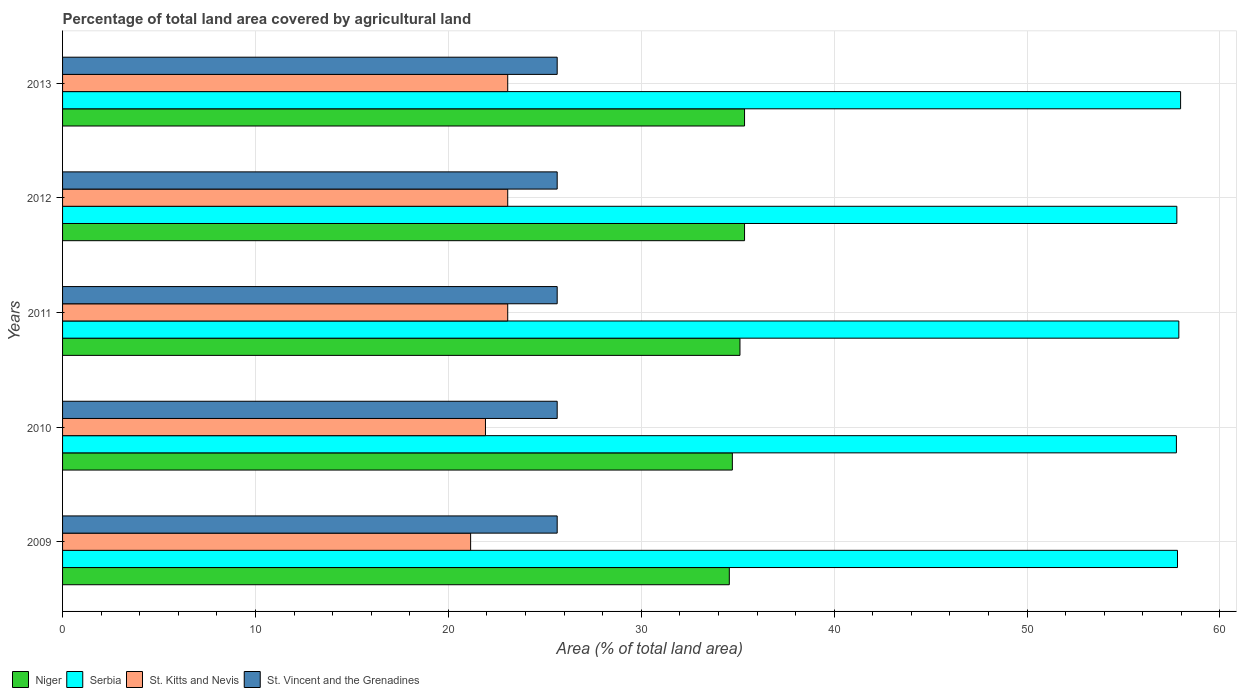How many different coloured bars are there?
Ensure brevity in your answer.  4. Are the number of bars per tick equal to the number of legend labels?
Offer a terse response. Yes. What is the percentage of agricultural land in St. Kitts and Nevis in 2013?
Provide a short and direct response. 23.08. Across all years, what is the maximum percentage of agricultural land in St. Vincent and the Grenadines?
Offer a very short reply. 25.64. Across all years, what is the minimum percentage of agricultural land in Serbia?
Give a very brief answer. 57.74. In which year was the percentage of agricultural land in Niger maximum?
Make the answer very short. 2012. In which year was the percentage of agricultural land in St. Kitts and Nevis minimum?
Offer a very short reply. 2009. What is the total percentage of agricultural land in Niger in the graph?
Make the answer very short. 175.11. What is the difference between the percentage of agricultural land in St. Kitts and Nevis in 2009 and that in 2010?
Make the answer very short. -0.77. What is the difference between the percentage of agricultural land in St. Vincent and the Grenadines in 2011 and the percentage of agricultural land in Serbia in 2013?
Your answer should be compact. -32.32. What is the average percentage of agricultural land in Serbia per year?
Your answer should be compact. 57.83. In the year 2013, what is the difference between the percentage of agricultural land in St. Kitts and Nevis and percentage of agricultural land in Niger?
Provide a short and direct response. -12.28. In how many years, is the percentage of agricultural land in St. Vincent and the Grenadines greater than 18 %?
Provide a succinct answer. 5. What is the ratio of the percentage of agricultural land in Niger in 2010 to that in 2012?
Offer a terse response. 0.98. What is the difference between the highest and the lowest percentage of agricultural land in Serbia?
Offer a very short reply. 0.22. In how many years, is the percentage of agricultural land in St. Vincent and the Grenadines greater than the average percentage of agricultural land in St. Vincent and the Grenadines taken over all years?
Ensure brevity in your answer.  0. Is it the case that in every year, the sum of the percentage of agricultural land in St. Kitts and Nevis and percentage of agricultural land in Serbia is greater than the sum of percentage of agricultural land in Niger and percentage of agricultural land in St. Vincent and the Grenadines?
Provide a succinct answer. Yes. What does the 2nd bar from the top in 2013 represents?
Make the answer very short. St. Kitts and Nevis. What does the 4th bar from the bottom in 2012 represents?
Offer a very short reply. St. Vincent and the Grenadines. Is it the case that in every year, the sum of the percentage of agricultural land in Niger and percentage of agricultural land in St. Kitts and Nevis is greater than the percentage of agricultural land in St. Vincent and the Grenadines?
Provide a short and direct response. Yes. How many bars are there?
Your answer should be compact. 20. Are all the bars in the graph horizontal?
Keep it short and to the point. Yes. How many years are there in the graph?
Keep it short and to the point. 5. Does the graph contain grids?
Offer a terse response. Yes. Where does the legend appear in the graph?
Provide a short and direct response. Bottom left. How many legend labels are there?
Offer a very short reply. 4. How are the legend labels stacked?
Your response must be concise. Horizontal. What is the title of the graph?
Make the answer very short. Percentage of total land area covered by agricultural land. What is the label or title of the X-axis?
Ensure brevity in your answer.  Area (% of total land area). What is the Area (% of total land area) of Niger in 2009?
Keep it short and to the point. 34.56. What is the Area (% of total land area) of Serbia in 2009?
Offer a very short reply. 57.8. What is the Area (% of total land area) in St. Kitts and Nevis in 2009?
Your answer should be compact. 21.15. What is the Area (% of total land area) of St. Vincent and the Grenadines in 2009?
Your response must be concise. 25.64. What is the Area (% of total land area) in Niger in 2010?
Make the answer very short. 34.72. What is the Area (% of total land area) of Serbia in 2010?
Make the answer very short. 57.74. What is the Area (% of total land area) in St. Kitts and Nevis in 2010?
Make the answer very short. 21.92. What is the Area (% of total land area) of St. Vincent and the Grenadines in 2010?
Offer a terse response. 25.64. What is the Area (% of total land area) in Niger in 2011?
Your answer should be very brief. 35.12. What is the Area (% of total land area) in Serbia in 2011?
Offer a very short reply. 57.87. What is the Area (% of total land area) in St. Kitts and Nevis in 2011?
Provide a short and direct response. 23.08. What is the Area (% of total land area) in St. Vincent and the Grenadines in 2011?
Provide a succinct answer. 25.64. What is the Area (% of total land area) of Niger in 2012?
Make the answer very short. 35.35. What is the Area (% of total land area) of Serbia in 2012?
Your answer should be compact. 57.76. What is the Area (% of total land area) in St. Kitts and Nevis in 2012?
Ensure brevity in your answer.  23.08. What is the Area (% of total land area) of St. Vincent and the Grenadines in 2012?
Offer a terse response. 25.64. What is the Area (% of total land area) of Niger in 2013?
Your response must be concise. 35.35. What is the Area (% of total land area) of Serbia in 2013?
Give a very brief answer. 57.96. What is the Area (% of total land area) of St. Kitts and Nevis in 2013?
Ensure brevity in your answer.  23.08. What is the Area (% of total land area) in St. Vincent and the Grenadines in 2013?
Give a very brief answer. 25.64. Across all years, what is the maximum Area (% of total land area) of Niger?
Offer a very short reply. 35.35. Across all years, what is the maximum Area (% of total land area) of Serbia?
Make the answer very short. 57.96. Across all years, what is the maximum Area (% of total land area) of St. Kitts and Nevis?
Keep it short and to the point. 23.08. Across all years, what is the maximum Area (% of total land area) of St. Vincent and the Grenadines?
Your answer should be very brief. 25.64. Across all years, what is the minimum Area (% of total land area) in Niger?
Make the answer very short. 34.56. Across all years, what is the minimum Area (% of total land area) of Serbia?
Give a very brief answer. 57.74. Across all years, what is the minimum Area (% of total land area) in St. Kitts and Nevis?
Ensure brevity in your answer.  21.15. Across all years, what is the minimum Area (% of total land area) in St. Vincent and the Grenadines?
Provide a succinct answer. 25.64. What is the total Area (% of total land area) in Niger in the graph?
Ensure brevity in your answer.  175.11. What is the total Area (% of total land area) in Serbia in the graph?
Provide a succinct answer. 289.13. What is the total Area (% of total land area) in St. Kitts and Nevis in the graph?
Make the answer very short. 112.31. What is the total Area (% of total land area) in St. Vincent and the Grenadines in the graph?
Provide a short and direct response. 128.21. What is the difference between the Area (% of total land area) of Niger in 2009 and that in 2010?
Offer a very short reply. -0.16. What is the difference between the Area (% of total land area) in Serbia in 2009 and that in 2010?
Offer a terse response. 0.06. What is the difference between the Area (% of total land area) in St. Kitts and Nevis in 2009 and that in 2010?
Your answer should be compact. -0.77. What is the difference between the Area (% of total land area) in St. Vincent and the Grenadines in 2009 and that in 2010?
Give a very brief answer. 0. What is the difference between the Area (% of total land area) of Niger in 2009 and that in 2011?
Your answer should be compact. -0.55. What is the difference between the Area (% of total land area) in Serbia in 2009 and that in 2011?
Your answer should be very brief. -0.07. What is the difference between the Area (% of total land area) in St. Kitts and Nevis in 2009 and that in 2011?
Your answer should be very brief. -1.92. What is the difference between the Area (% of total land area) in Niger in 2009 and that in 2012?
Provide a succinct answer. -0.79. What is the difference between the Area (% of total land area) of Serbia in 2009 and that in 2012?
Make the answer very short. 0.03. What is the difference between the Area (% of total land area) in St. Kitts and Nevis in 2009 and that in 2012?
Give a very brief answer. -1.92. What is the difference between the Area (% of total land area) in St. Vincent and the Grenadines in 2009 and that in 2012?
Provide a short and direct response. 0. What is the difference between the Area (% of total land area) in Niger in 2009 and that in 2013?
Your answer should be very brief. -0.79. What is the difference between the Area (% of total land area) in Serbia in 2009 and that in 2013?
Your answer should be compact. -0.16. What is the difference between the Area (% of total land area) in St. Kitts and Nevis in 2009 and that in 2013?
Provide a succinct answer. -1.92. What is the difference between the Area (% of total land area) of St. Vincent and the Grenadines in 2009 and that in 2013?
Keep it short and to the point. 0. What is the difference between the Area (% of total land area) in Niger in 2010 and that in 2011?
Your answer should be very brief. -0.39. What is the difference between the Area (% of total land area) in Serbia in 2010 and that in 2011?
Make the answer very short. -0.13. What is the difference between the Area (% of total land area) of St. Kitts and Nevis in 2010 and that in 2011?
Make the answer very short. -1.15. What is the difference between the Area (% of total land area) of Niger in 2010 and that in 2012?
Keep it short and to the point. -0.63. What is the difference between the Area (% of total land area) of Serbia in 2010 and that in 2012?
Ensure brevity in your answer.  -0.02. What is the difference between the Area (% of total land area) of St. Kitts and Nevis in 2010 and that in 2012?
Make the answer very short. -1.15. What is the difference between the Area (% of total land area) in St. Vincent and the Grenadines in 2010 and that in 2012?
Provide a succinct answer. 0. What is the difference between the Area (% of total land area) of Niger in 2010 and that in 2013?
Ensure brevity in your answer.  -0.63. What is the difference between the Area (% of total land area) in Serbia in 2010 and that in 2013?
Provide a short and direct response. -0.22. What is the difference between the Area (% of total land area) in St. Kitts and Nevis in 2010 and that in 2013?
Ensure brevity in your answer.  -1.15. What is the difference between the Area (% of total land area) of St. Vincent and the Grenadines in 2010 and that in 2013?
Provide a succinct answer. 0. What is the difference between the Area (% of total land area) of Niger in 2011 and that in 2012?
Your answer should be compact. -0.24. What is the difference between the Area (% of total land area) in Serbia in 2011 and that in 2012?
Provide a succinct answer. 0.1. What is the difference between the Area (% of total land area) in Niger in 2011 and that in 2013?
Your response must be concise. -0.24. What is the difference between the Area (% of total land area) of Serbia in 2011 and that in 2013?
Provide a succinct answer. -0.09. What is the difference between the Area (% of total land area) of St. Kitts and Nevis in 2011 and that in 2013?
Your answer should be very brief. 0. What is the difference between the Area (% of total land area) of St. Vincent and the Grenadines in 2011 and that in 2013?
Provide a short and direct response. 0. What is the difference between the Area (% of total land area) of Niger in 2012 and that in 2013?
Keep it short and to the point. 0. What is the difference between the Area (% of total land area) in Serbia in 2012 and that in 2013?
Provide a short and direct response. -0.19. What is the difference between the Area (% of total land area) of St. Kitts and Nevis in 2012 and that in 2013?
Provide a short and direct response. 0. What is the difference between the Area (% of total land area) of St. Vincent and the Grenadines in 2012 and that in 2013?
Your answer should be compact. 0. What is the difference between the Area (% of total land area) in Niger in 2009 and the Area (% of total land area) in Serbia in 2010?
Offer a very short reply. -23.18. What is the difference between the Area (% of total land area) in Niger in 2009 and the Area (% of total land area) in St. Kitts and Nevis in 2010?
Make the answer very short. 12.64. What is the difference between the Area (% of total land area) in Niger in 2009 and the Area (% of total land area) in St. Vincent and the Grenadines in 2010?
Your response must be concise. 8.92. What is the difference between the Area (% of total land area) of Serbia in 2009 and the Area (% of total land area) of St. Kitts and Nevis in 2010?
Your answer should be compact. 35.87. What is the difference between the Area (% of total land area) of Serbia in 2009 and the Area (% of total land area) of St. Vincent and the Grenadines in 2010?
Your answer should be compact. 32.16. What is the difference between the Area (% of total land area) of St. Kitts and Nevis in 2009 and the Area (% of total land area) of St. Vincent and the Grenadines in 2010?
Provide a succinct answer. -4.49. What is the difference between the Area (% of total land area) in Niger in 2009 and the Area (% of total land area) in Serbia in 2011?
Give a very brief answer. -23.3. What is the difference between the Area (% of total land area) in Niger in 2009 and the Area (% of total land area) in St. Kitts and Nevis in 2011?
Offer a terse response. 11.49. What is the difference between the Area (% of total land area) of Niger in 2009 and the Area (% of total land area) of St. Vincent and the Grenadines in 2011?
Your answer should be very brief. 8.92. What is the difference between the Area (% of total land area) in Serbia in 2009 and the Area (% of total land area) in St. Kitts and Nevis in 2011?
Ensure brevity in your answer.  34.72. What is the difference between the Area (% of total land area) in Serbia in 2009 and the Area (% of total land area) in St. Vincent and the Grenadines in 2011?
Your answer should be very brief. 32.16. What is the difference between the Area (% of total land area) in St. Kitts and Nevis in 2009 and the Area (% of total land area) in St. Vincent and the Grenadines in 2011?
Give a very brief answer. -4.49. What is the difference between the Area (% of total land area) of Niger in 2009 and the Area (% of total land area) of Serbia in 2012?
Provide a succinct answer. -23.2. What is the difference between the Area (% of total land area) of Niger in 2009 and the Area (% of total land area) of St. Kitts and Nevis in 2012?
Ensure brevity in your answer.  11.49. What is the difference between the Area (% of total land area) of Niger in 2009 and the Area (% of total land area) of St. Vincent and the Grenadines in 2012?
Ensure brevity in your answer.  8.92. What is the difference between the Area (% of total land area) of Serbia in 2009 and the Area (% of total land area) of St. Kitts and Nevis in 2012?
Provide a succinct answer. 34.72. What is the difference between the Area (% of total land area) of Serbia in 2009 and the Area (% of total land area) of St. Vincent and the Grenadines in 2012?
Your response must be concise. 32.16. What is the difference between the Area (% of total land area) of St. Kitts and Nevis in 2009 and the Area (% of total land area) of St. Vincent and the Grenadines in 2012?
Offer a very short reply. -4.49. What is the difference between the Area (% of total land area) in Niger in 2009 and the Area (% of total land area) in Serbia in 2013?
Keep it short and to the point. -23.39. What is the difference between the Area (% of total land area) in Niger in 2009 and the Area (% of total land area) in St. Kitts and Nevis in 2013?
Ensure brevity in your answer.  11.49. What is the difference between the Area (% of total land area) in Niger in 2009 and the Area (% of total land area) in St. Vincent and the Grenadines in 2013?
Offer a very short reply. 8.92. What is the difference between the Area (% of total land area) of Serbia in 2009 and the Area (% of total land area) of St. Kitts and Nevis in 2013?
Provide a short and direct response. 34.72. What is the difference between the Area (% of total land area) in Serbia in 2009 and the Area (% of total land area) in St. Vincent and the Grenadines in 2013?
Your answer should be compact. 32.16. What is the difference between the Area (% of total land area) of St. Kitts and Nevis in 2009 and the Area (% of total land area) of St. Vincent and the Grenadines in 2013?
Make the answer very short. -4.49. What is the difference between the Area (% of total land area) of Niger in 2010 and the Area (% of total land area) of Serbia in 2011?
Make the answer very short. -23.14. What is the difference between the Area (% of total land area) in Niger in 2010 and the Area (% of total land area) in St. Kitts and Nevis in 2011?
Your answer should be very brief. 11.64. What is the difference between the Area (% of total land area) in Niger in 2010 and the Area (% of total land area) in St. Vincent and the Grenadines in 2011?
Your response must be concise. 9.08. What is the difference between the Area (% of total land area) of Serbia in 2010 and the Area (% of total land area) of St. Kitts and Nevis in 2011?
Give a very brief answer. 34.66. What is the difference between the Area (% of total land area) in Serbia in 2010 and the Area (% of total land area) in St. Vincent and the Grenadines in 2011?
Keep it short and to the point. 32.1. What is the difference between the Area (% of total land area) in St. Kitts and Nevis in 2010 and the Area (% of total land area) in St. Vincent and the Grenadines in 2011?
Give a very brief answer. -3.72. What is the difference between the Area (% of total land area) in Niger in 2010 and the Area (% of total land area) in Serbia in 2012?
Keep it short and to the point. -23.04. What is the difference between the Area (% of total land area) of Niger in 2010 and the Area (% of total land area) of St. Kitts and Nevis in 2012?
Keep it short and to the point. 11.64. What is the difference between the Area (% of total land area) of Niger in 2010 and the Area (% of total land area) of St. Vincent and the Grenadines in 2012?
Your answer should be very brief. 9.08. What is the difference between the Area (% of total land area) in Serbia in 2010 and the Area (% of total land area) in St. Kitts and Nevis in 2012?
Ensure brevity in your answer.  34.66. What is the difference between the Area (% of total land area) in Serbia in 2010 and the Area (% of total land area) in St. Vincent and the Grenadines in 2012?
Make the answer very short. 32.1. What is the difference between the Area (% of total land area) of St. Kitts and Nevis in 2010 and the Area (% of total land area) of St. Vincent and the Grenadines in 2012?
Ensure brevity in your answer.  -3.72. What is the difference between the Area (% of total land area) of Niger in 2010 and the Area (% of total land area) of Serbia in 2013?
Give a very brief answer. -23.24. What is the difference between the Area (% of total land area) of Niger in 2010 and the Area (% of total land area) of St. Kitts and Nevis in 2013?
Ensure brevity in your answer.  11.64. What is the difference between the Area (% of total land area) in Niger in 2010 and the Area (% of total land area) in St. Vincent and the Grenadines in 2013?
Your response must be concise. 9.08. What is the difference between the Area (% of total land area) of Serbia in 2010 and the Area (% of total land area) of St. Kitts and Nevis in 2013?
Give a very brief answer. 34.66. What is the difference between the Area (% of total land area) in Serbia in 2010 and the Area (% of total land area) in St. Vincent and the Grenadines in 2013?
Make the answer very short. 32.1. What is the difference between the Area (% of total land area) in St. Kitts and Nevis in 2010 and the Area (% of total land area) in St. Vincent and the Grenadines in 2013?
Offer a very short reply. -3.72. What is the difference between the Area (% of total land area) in Niger in 2011 and the Area (% of total land area) in Serbia in 2012?
Your answer should be compact. -22.65. What is the difference between the Area (% of total land area) of Niger in 2011 and the Area (% of total land area) of St. Kitts and Nevis in 2012?
Offer a terse response. 12.04. What is the difference between the Area (% of total land area) in Niger in 2011 and the Area (% of total land area) in St. Vincent and the Grenadines in 2012?
Offer a very short reply. 9.48. What is the difference between the Area (% of total land area) in Serbia in 2011 and the Area (% of total land area) in St. Kitts and Nevis in 2012?
Your answer should be compact. 34.79. What is the difference between the Area (% of total land area) in Serbia in 2011 and the Area (% of total land area) in St. Vincent and the Grenadines in 2012?
Make the answer very short. 32.23. What is the difference between the Area (% of total land area) of St. Kitts and Nevis in 2011 and the Area (% of total land area) of St. Vincent and the Grenadines in 2012?
Keep it short and to the point. -2.56. What is the difference between the Area (% of total land area) in Niger in 2011 and the Area (% of total land area) in Serbia in 2013?
Provide a succinct answer. -22.84. What is the difference between the Area (% of total land area) in Niger in 2011 and the Area (% of total land area) in St. Kitts and Nevis in 2013?
Offer a very short reply. 12.04. What is the difference between the Area (% of total land area) in Niger in 2011 and the Area (% of total land area) in St. Vincent and the Grenadines in 2013?
Offer a terse response. 9.48. What is the difference between the Area (% of total land area) in Serbia in 2011 and the Area (% of total land area) in St. Kitts and Nevis in 2013?
Provide a succinct answer. 34.79. What is the difference between the Area (% of total land area) in Serbia in 2011 and the Area (% of total land area) in St. Vincent and the Grenadines in 2013?
Provide a succinct answer. 32.23. What is the difference between the Area (% of total land area) in St. Kitts and Nevis in 2011 and the Area (% of total land area) in St. Vincent and the Grenadines in 2013?
Your answer should be very brief. -2.56. What is the difference between the Area (% of total land area) of Niger in 2012 and the Area (% of total land area) of Serbia in 2013?
Your response must be concise. -22.6. What is the difference between the Area (% of total land area) of Niger in 2012 and the Area (% of total land area) of St. Kitts and Nevis in 2013?
Your response must be concise. 12.28. What is the difference between the Area (% of total land area) in Niger in 2012 and the Area (% of total land area) in St. Vincent and the Grenadines in 2013?
Your answer should be compact. 9.71. What is the difference between the Area (% of total land area) in Serbia in 2012 and the Area (% of total land area) in St. Kitts and Nevis in 2013?
Your answer should be compact. 34.69. What is the difference between the Area (% of total land area) of Serbia in 2012 and the Area (% of total land area) of St. Vincent and the Grenadines in 2013?
Your response must be concise. 32.12. What is the difference between the Area (% of total land area) of St. Kitts and Nevis in 2012 and the Area (% of total land area) of St. Vincent and the Grenadines in 2013?
Offer a terse response. -2.56. What is the average Area (% of total land area) in Niger per year?
Your response must be concise. 35.02. What is the average Area (% of total land area) in Serbia per year?
Provide a succinct answer. 57.83. What is the average Area (% of total land area) in St. Kitts and Nevis per year?
Provide a short and direct response. 22.46. What is the average Area (% of total land area) in St. Vincent and the Grenadines per year?
Offer a very short reply. 25.64. In the year 2009, what is the difference between the Area (% of total land area) in Niger and Area (% of total land area) in Serbia?
Your answer should be very brief. -23.23. In the year 2009, what is the difference between the Area (% of total land area) of Niger and Area (% of total land area) of St. Kitts and Nevis?
Ensure brevity in your answer.  13.41. In the year 2009, what is the difference between the Area (% of total land area) of Niger and Area (% of total land area) of St. Vincent and the Grenadines?
Your response must be concise. 8.92. In the year 2009, what is the difference between the Area (% of total land area) of Serbia and Area (% of total land area) of St. Kitts and Nevis?
Provide a short and direct response. 36.64. In the year 2009, what is the difference between the Area (% of total land area) in Serbia and Area (% of total land area) in St. Vincent and the Grenadines?
Offer a terse response. 32.16. In the year 2009, what is the difference between the Area (% of total land area) of St. Kitts and Nevis and Area (% of total land area) of St. Vincent and the Grenadines?
Offer a terse response. -4.49. In the year 2010, what is the difference between the Area (% of total land area) of Niger and Area (% of total land area) of Serbia?
Ensure brevity in your answer.  -23.02. In the year 2010, what is the difference between the Area (% of total land area) of Niger and Area (% of total land area) of St. Kitts and Nevis?
Your answer should be very brief. 12.8. In the year 2010, what is the difference between the Area (% of total land area) in Niger and Area (% of total land area) in St. Vincent and the Grenadines?
Keep it short and to the point. 9.08. In the year 2010, what is the difference between the Area (% of total land area) of Serbia and Area (% of total land area) of St. Kitts and Nevis?
Give a very brief answer. 35.82. In the year 2010, what is the difference between the Area (% of total land area) of Serbia and Area (% of total land area) of St. Vincent and the Grenadines?
Give a very brief answer. 32.1. In the year 2010, what is the difference between the Area (% of total land area) of St. Kitts and Nevis and Area (% of total land area) of St. Vincent and the Grenadines?
Give a very brief answer. -3.72. In the year 2011, what is the difference between the Area (% of total land area) of Niger and Area (% of total land area) of Serbia?
Keep it short and to the point. -22.75. In the year 2011, what is the difference between the Area (% of total land area) of Niger and Area (% of total land area) of St. Kitts and Nevis?
Provide a succinct answer. 12.04. In the year 2011, what is the difference between the Area (% of total land area) in Niger and Area (% of total land area) in St. Vincent and the Grenadines?
Keep it short and to the point. 9.48. In the year 2011, what is the difference between the Area (% of total land area) of Serbia and Area (% of total land area) of St. Kitts and Nevis?
Provide a succinct answer. 34.79. In the year 2011, what is the difference between the Area (% of total land area) in Serbia and Area (% of total land area) in St. Vincent and the Grenadines?
Make the answer very short. 32.23. In the year 2011, what is the difference between the Area (% of total land area) of St. Kitts and Nevis and Area (% of total land area) of St. Vincent and the Grenadines?
Make the answer very short. -2.56. In the year 2012, what is the difference between the Area (% of total land area) of Niger and Area (% of total land area) of Serbia?
Your answer should be very brief. -22.41. In the year 2012, what is the difference between the Area (% of total land area) in Niger and Area (% of total land area) in St. Kitts and Nevis?
Your response must be concise. 12.28. In the year 2012, what is the difference between the Area (% of total land area) of Niger and Area (% of total land area) of St. Vincent and the Grenadines?
Provide a short and direct response. 9.71. In the year 2012, what is the difference between the Area (% of total land area) of Serbia and Area (% of total land area) of St. Kitts and Nevis?
Your answer should be very brief. 34.69. In the year 2012, what is the difference between the Area (% of total land area) of Serbia and Area (% of total land area) of St. Vincent and the Grenadines?
Your response must be concise. 32.12. In the year 2012, what is the difference between the Area (% of total land area) in St. Kitts and Nevis and Area (% of total land area) in St. Vincent and the Grenadines?
Your answer should be compact. -2.56. In the year 2013, what is the difference between the Area (% of total land area) in Niger and Area (% of total land area) in Serbia?
Your response must be concise. -22.6. In the year 2013, what is the difference between the Area (% of total land area) in Niger and Area (% of total land area) in St. Kitts and Nevis?
Make the answer very short. 12.28. In the year 2013, what is the difference between the Area (% of total land area) in Niger and Area (% of total land area) in St. Vincent and the Grenadines?
Ensure brevity in your answer.  9.71. In the year 2013, what is the difference between the Area (% of total land area) of Serbia and Area (% of total land area) of St. Kitts and Nevis?
Make the answer very short. 34.88. In the year 2013, what is the difference between the Area (% of total land area) in Serbia and Area (% of total land area) in St. Vincent and the Grenadines?
Make the answer very short. 32.32. In the year 2013, what is the difference between the Area (% of total land area) in St. Kitts and Nevis and Area (% of total land area) in St. Vincent and the Grenadines?
Offer a terse response. -2.56. What is the ratio of the Area (% of total land area) of Serbia in 2009 to that in 2010?
Your answer should be compact. 1. What is the ratio of the Area (% of total land area) in St. Kitts and Nevis in 2009 to that in 2010?
Provide a short and direct response. 0.96. What is the ratio of the Area (% of total land area) in St. Vincent and the Grenadines in 2009 to that in 2010?
Provide a short and direct response. 1. What is the ratio of the Area (% of total land area) in Niger in 2009 to that in 2011?
Provide a short and direct response. 0.98. What is the ratio of the Area (% of total land area) in St. Vincent and the Grenadines in 2009 to that in 2011?
Keep it short and to the point. 1. What is the ratio of the Area (% of total land area) of Niger in 2009 to that in 2012?
Give a very brief answer. 0.98. What is the ratio of the Area (% of total land area) in St. Kitts and Nevis in 2009 to that in 2012?
Offer a very short reply. 0.92. What is the ratio of the Area (% of total land area) in Niger in 2009 to that in 2013?
Provide a succinct answer. 0.98. What is the ratio of the Area (% of total land area) in St. Kitts and Nevis in 2009 to that in 2013?
Offer a very short reply. 0.92. What is the ratio of the Area (% of total land area) of Serbia in 2010 to that in 2011?
Offer a terse response. 1. What is the ratio of the Area (% of total land area) in St. Kitts and Nevis in 2010 to that in 2011?
Make the answer very short. 0.95. What is the ratio of the Area (% of total land area) of Niger in 2010 to that in 2012?
Make the answer very short. 0.98. What is the ratio of the Area (% of total land area) of St. Kitts and Nevis in 2010 to that in 2012?
Your answer should be very brief. 0.95. What is the ratio of the Area (% of total land area) of St. Vincent and the Grenadines in 2010 to that in 2012?
Give a very brief answer. 1. What is the ratio of the Area (% of total land area) of Niger in 2010 to that in 2013?
Make the answer very short. 0.98. What is the ratio of the Area (% of total land area) of Serbia in 2010 to that in 2013?
Provide a short and direct response. 1. What is the ratio of the Area (% of total land area) of St. Kitts and Nevis in 2010 to that in 2013?
Ensure brevity in your answer.  0.95. What is the ratio of the Area (% of total land area) in Niger in 2011 to that in 2013?
Keep it short and to the point. 0.99. What is the ratio of the Area (% of total land area) of St. Kitts and Nevis in 2011 to that in 2013?
Your answer should be very brief. 1. What is the ratio of the Area (% of total land area) in St. Vincent and the Grenadines in 2012 to that in 2013?
Your response must be concise. 1. What is the difference between the highest and the second highest Area (% of total land area) of Serbia?
Provide a succinct answer. 0.09. What is the difference between the highest and the lowest Area (% of total land area) of Niger?
Give a very brief answer. 0.79. What is the difference between the highest and the lowest Area (% of total land area) of Serbia?
Provide a succinct answer. 0.22. What is the difference between the highest and the lowest Area (% of total land area) of St. Kitts and Nevis?
Your response must be concise. 1.92. 